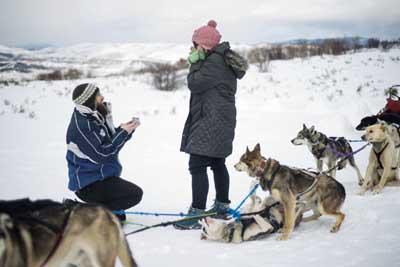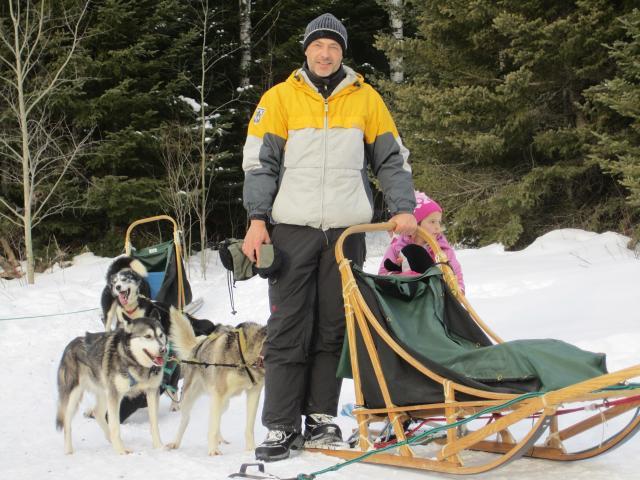The first image is the image on the left, the second image is the image on the right. Analyze the images presented: Is the assertion "A camera-facing person in winter clothing is hugging at least one dog to their front, and the dog's body is turned toward the camera too." valid? Answer yes or no. No. The first image is the image on the left, the second image is the image on the right. Assess this claim about the two images: "There is one person holding at least one dog.". Correct or not? Answer yes or no. No. 